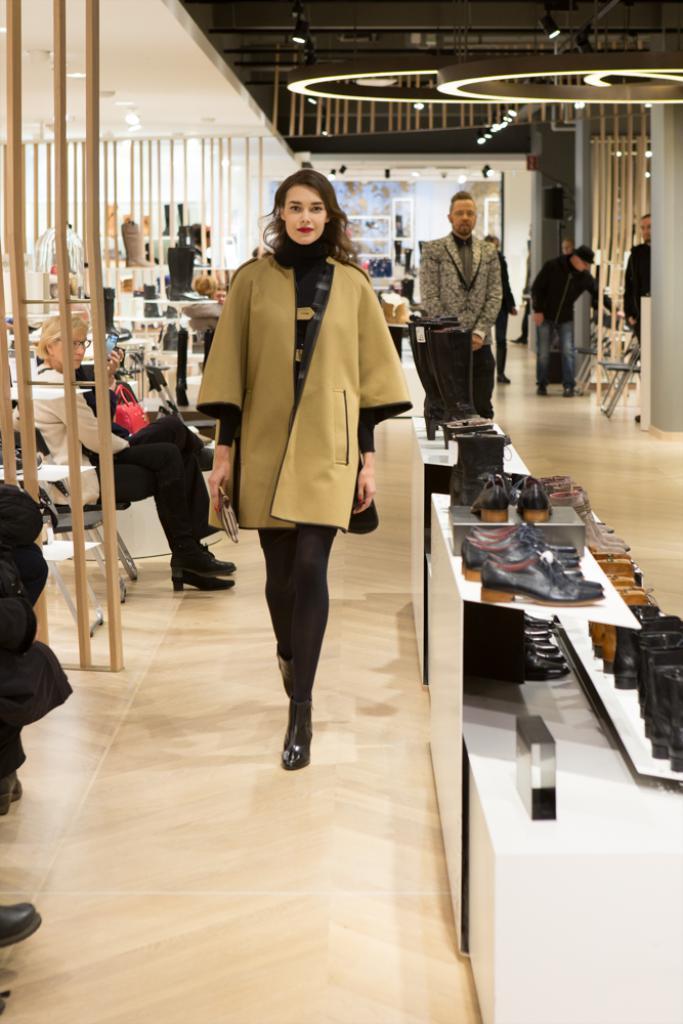How would you summarize this image in a sentence or two? In this image I see number of people in which most of them are sitting on chairs and I see that these 5 of them are standing and I see number of shoes over here and I see the floor. In the background I see the lights on the ceiling. 